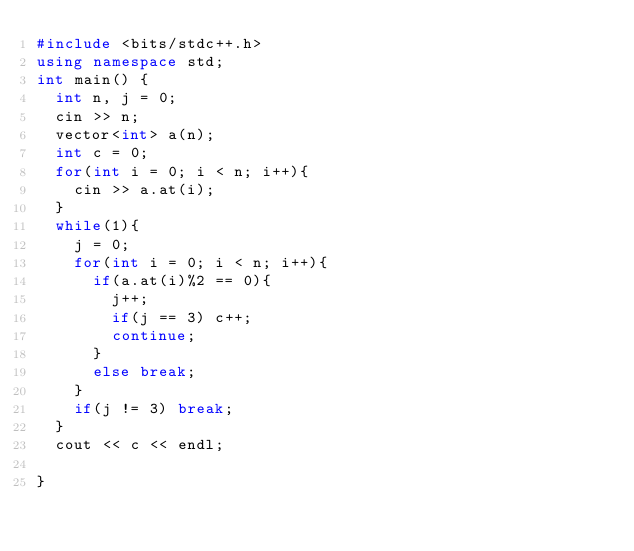Convert code to text. <code><loc_0><loc_0><loc_500><loc_500><_C++_>#include <bits/stdc++.h>
using namespace std;
int main() {
  int n, j = 0;
  cin >> n;
  vector<int> a(n);
  int c = 0;
  for(int i = 0; i < n; i++){
    cin >> a.at(i);
  }
  while(1){
    j = 0;
    for(int i = 0; i < n; i++){
      if(a.at(i)%2 == 0){
        j++;
        if(j == 3) c++;
        continue;
      }
      else break;
    }
    if(j != 3) break;
  }
  cout << c << endl;
  
}</code> 